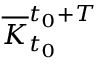<formula> <loc_0><loc_0><loc_500><loc_500>\overline { K } _ { t _ { 0 } } ^ { t _ { 0 } + T }</formula> 